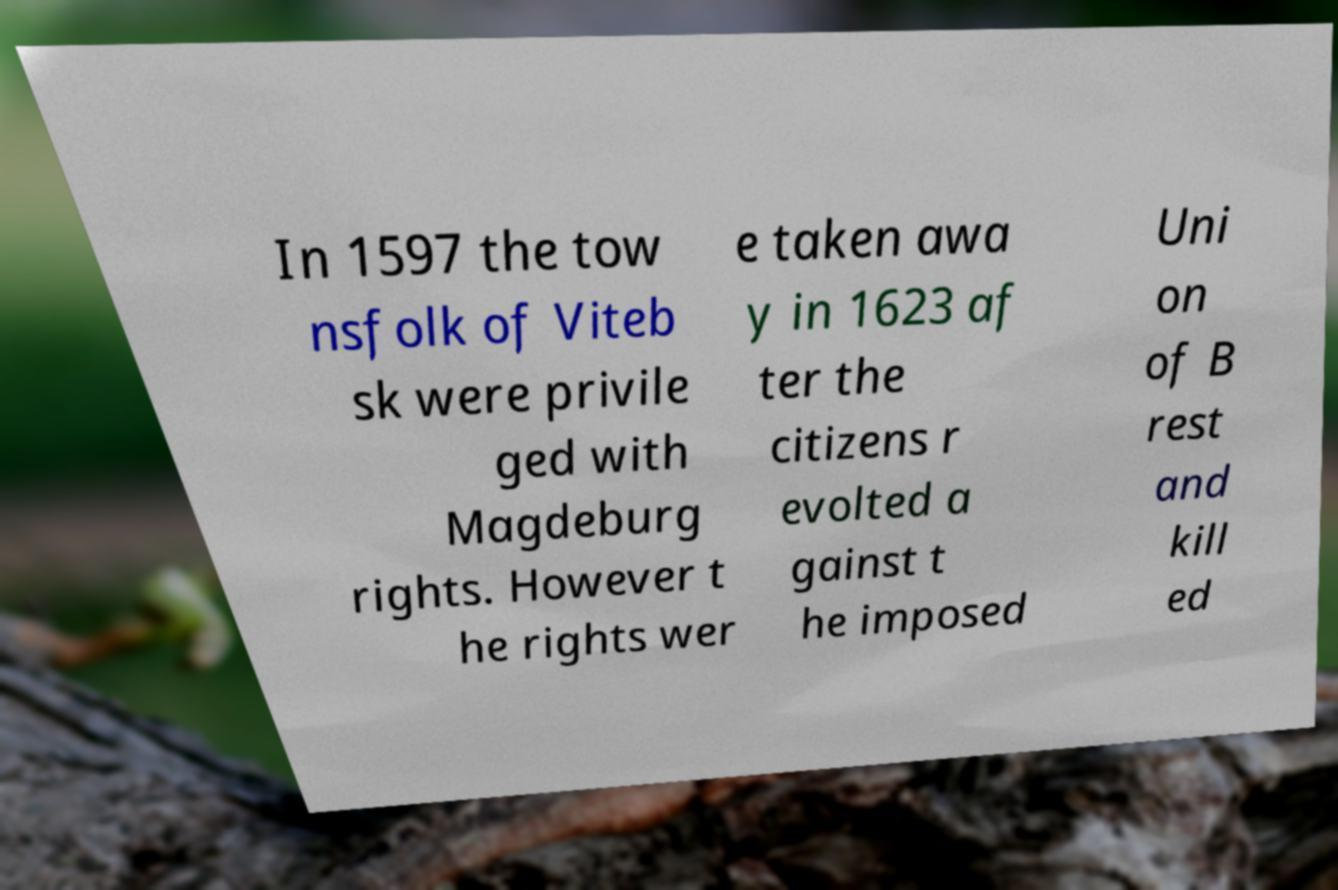Please identify and transcribe the text found in this image. In 1597 the tow nsfolk of Viteb sk were privile ged with Magdeburg rights. However t he rights wer e taken awa y in 1623 af ter the citizens r evolted a gainst t he imposed Uni on of B rest and kill ed 